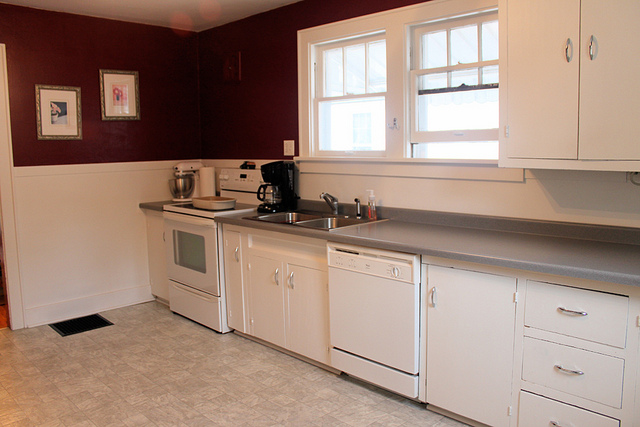Are there any paintings or artworks on the wall? Yes, there are two paintings on the wall, adding a touch of decor and personality to the kitchen. 